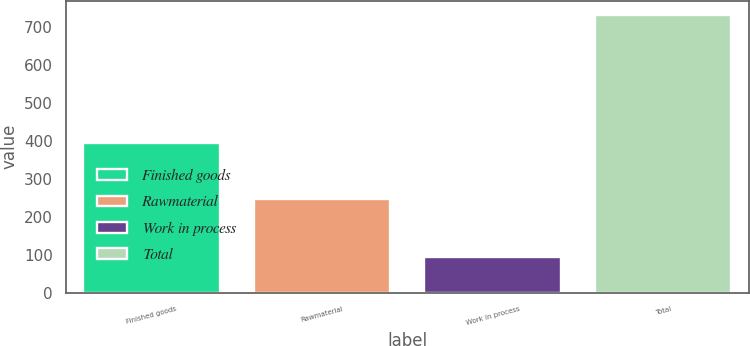Convert chart to OTSL. <chart><loc_0><loc_0><loc_500><loc_500><bar_chart><fcel>Finished goods<fcel>Rawmaterial<fcel>Work in process<fcel>Total<nl><fcel>393<fcel>246<fcel>93<fcel>732<nl></chart> 